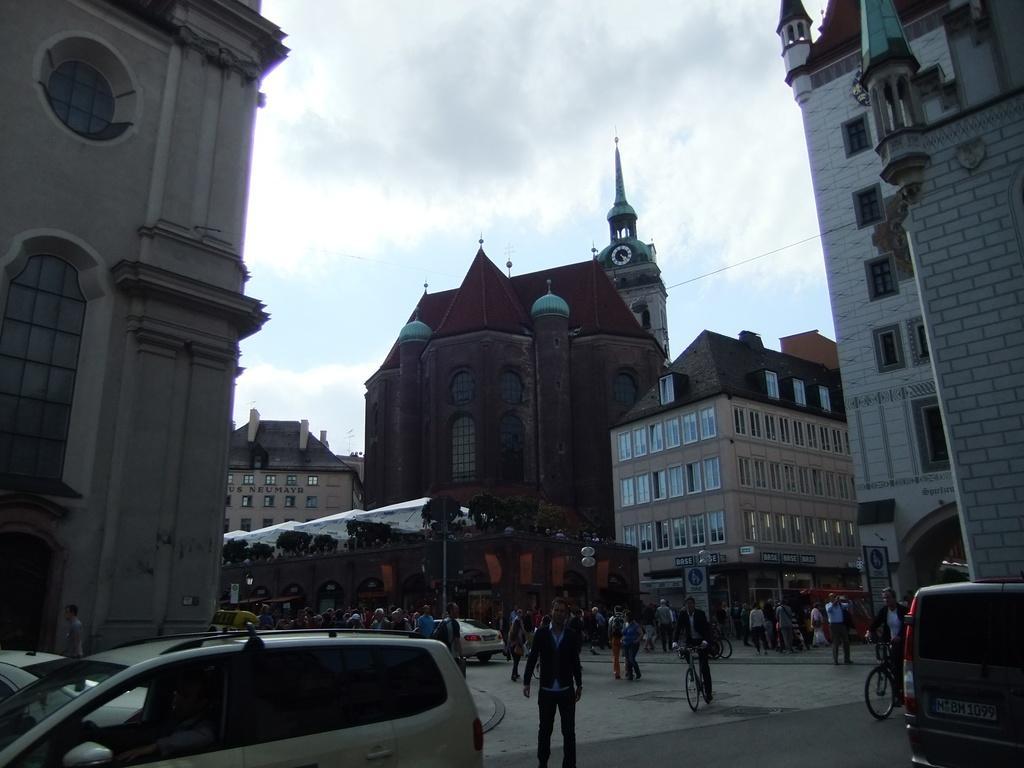Please provide a concise description of this image. We can see vehicles on the road and there are people and these people are riding bicycles. In the background we can see tent,plants,buildings and sky with clouds. 